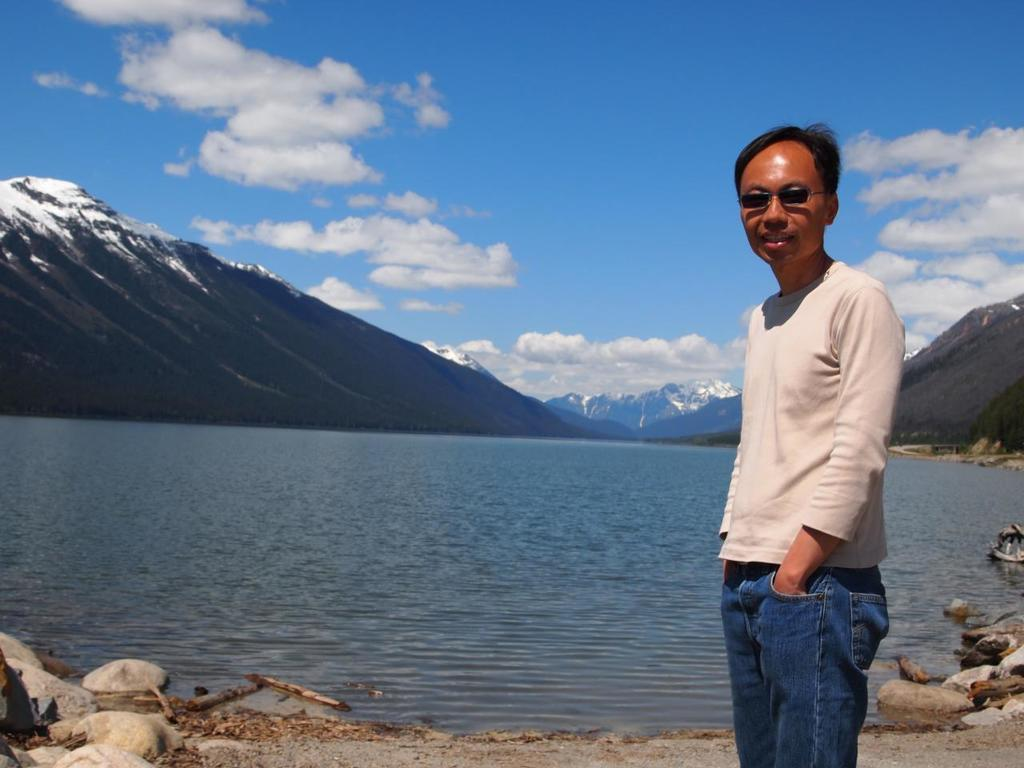What is the main subject of the image? There is a man in the image. What is the man doing in the image? The man is posing for a camera. What is the man wearing in the image? The man is wearing goggles. What can be seen in the background of the image? There is water, a mountain, and sky visible in the background of the image. What is the condition of the sky in the image? Clouds are present in the sky. What type of toothpaste is the man using in the image? There is no toothpaste present in the image. How does the man's digestion affect the water in the image? There is no indication of the man's digestion or its effect on the water in the image. 